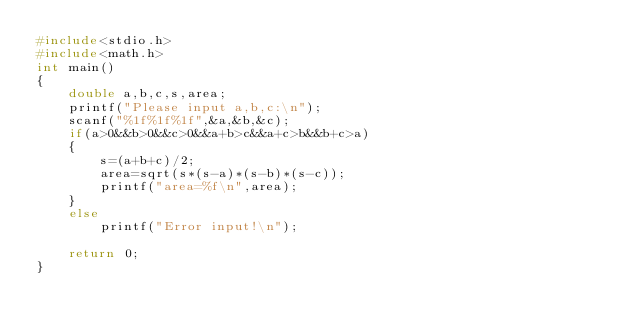Convert code to text. <code><loc_0><loc_0><loc_500><loc_500><_C_>#include<stdio.h>
#include<math.h>
int main()
{
    double a,b,c,s,area;
    printf("Please input a,b,c:\n");
    scanf("%1f%1f%1f",&a,&b,&c);
    if(a>0&&b>0&&c>0&&a+b>c&&a+c>b&&b+c>a)
    {
        s=(a+b+c)/2;
        area=sqrt(s*(s-a)*(s-b)*(s-c));
        printf("area=%f\n",area);
    }
    else
        printf("Error input!\n");

    return 0;
}</code> 